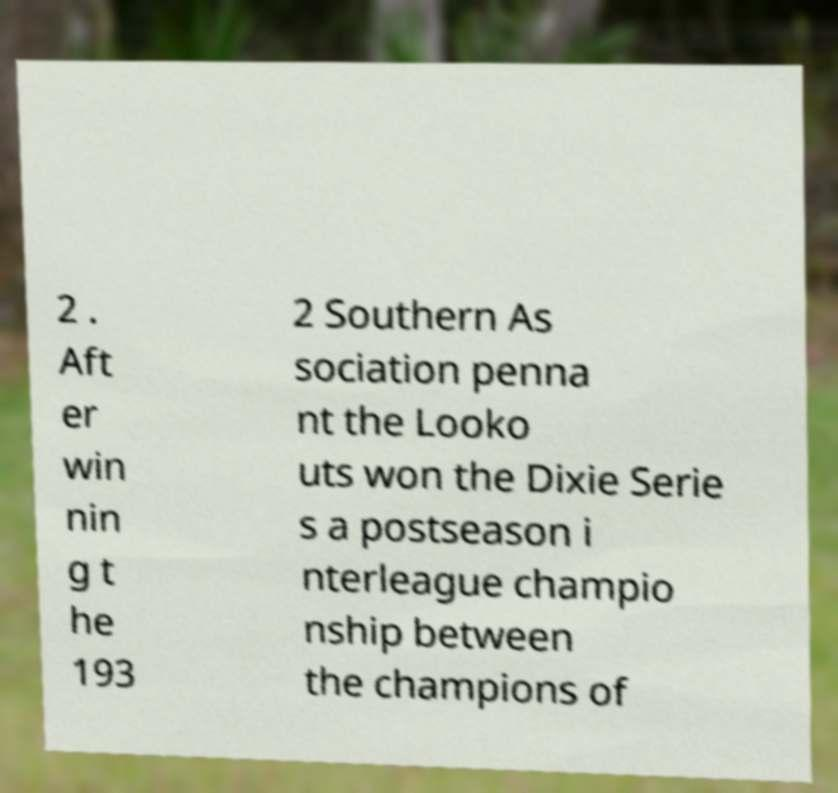Can you accurately transcribe the text from the provided image for me? 2 . Aft er win nin g t he 193 2 Southern As sociation penna nt the Looko uts won the Dixie Serie s a postseason i nterleague champio nship between the champions of 